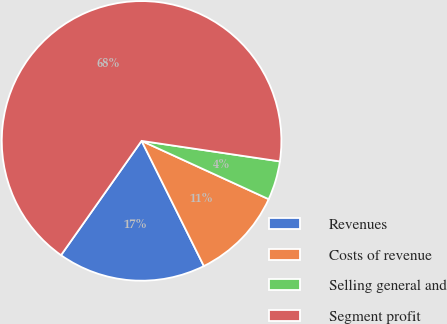Convert chart to OTSL. <chart><loc_0><loc_0><loc_500><loc_500><pie_chart><fcel>Revenues<fcel>Costs of revenue<fcel>Selling general and<fcel>Segment profit<nl><fcel>17.12%<fcel>10.81%<fcel>4.5%<fcel>67.57%<nl></chart> 